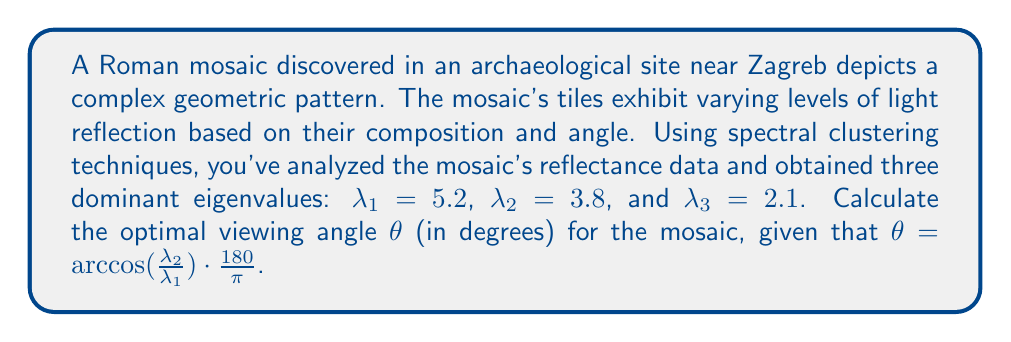Solve this math problem. To determine the optimal viewing angle for the Roman mosaic using the given spectral clustering data, we'll follow these steps:

1. Identify the relevant eigenvalues:
   $\lambda_1 = 5.2$ (largest eigenvalue)
   $\lambda_2 = 3.8$ (second largest eigenvalue)

2. Apply the given formula: $\theta = \arccos(\frac{\lambda_2}{\lambda_1}) \cdot \frac{180}{\pi}$

3. Calculate the ratio $\frac{\lambda_2}{\lambda_1}$:
   $$\frac{\lambda_2}{\lambda_1} = \frac{3.8}{5.2} \approx 0.7308$$

4. Calculate the arccosine of this ratio:
   $$\arccos(0.7308) \approx 0.7754 \text{ radians}$$

5. Convert radians to degrees by multiplying by $\frac{180}{\pi}$:
   $$0.7754 \cdot \frac{180}{\pi} \approx 44.43°$$

6. Round to the nearest degree:
   $$44.43° \approx 44°$$

Therefore, the optimal viewing angle for the Roman mosaic is approximately 44°.
Answer: 44° 